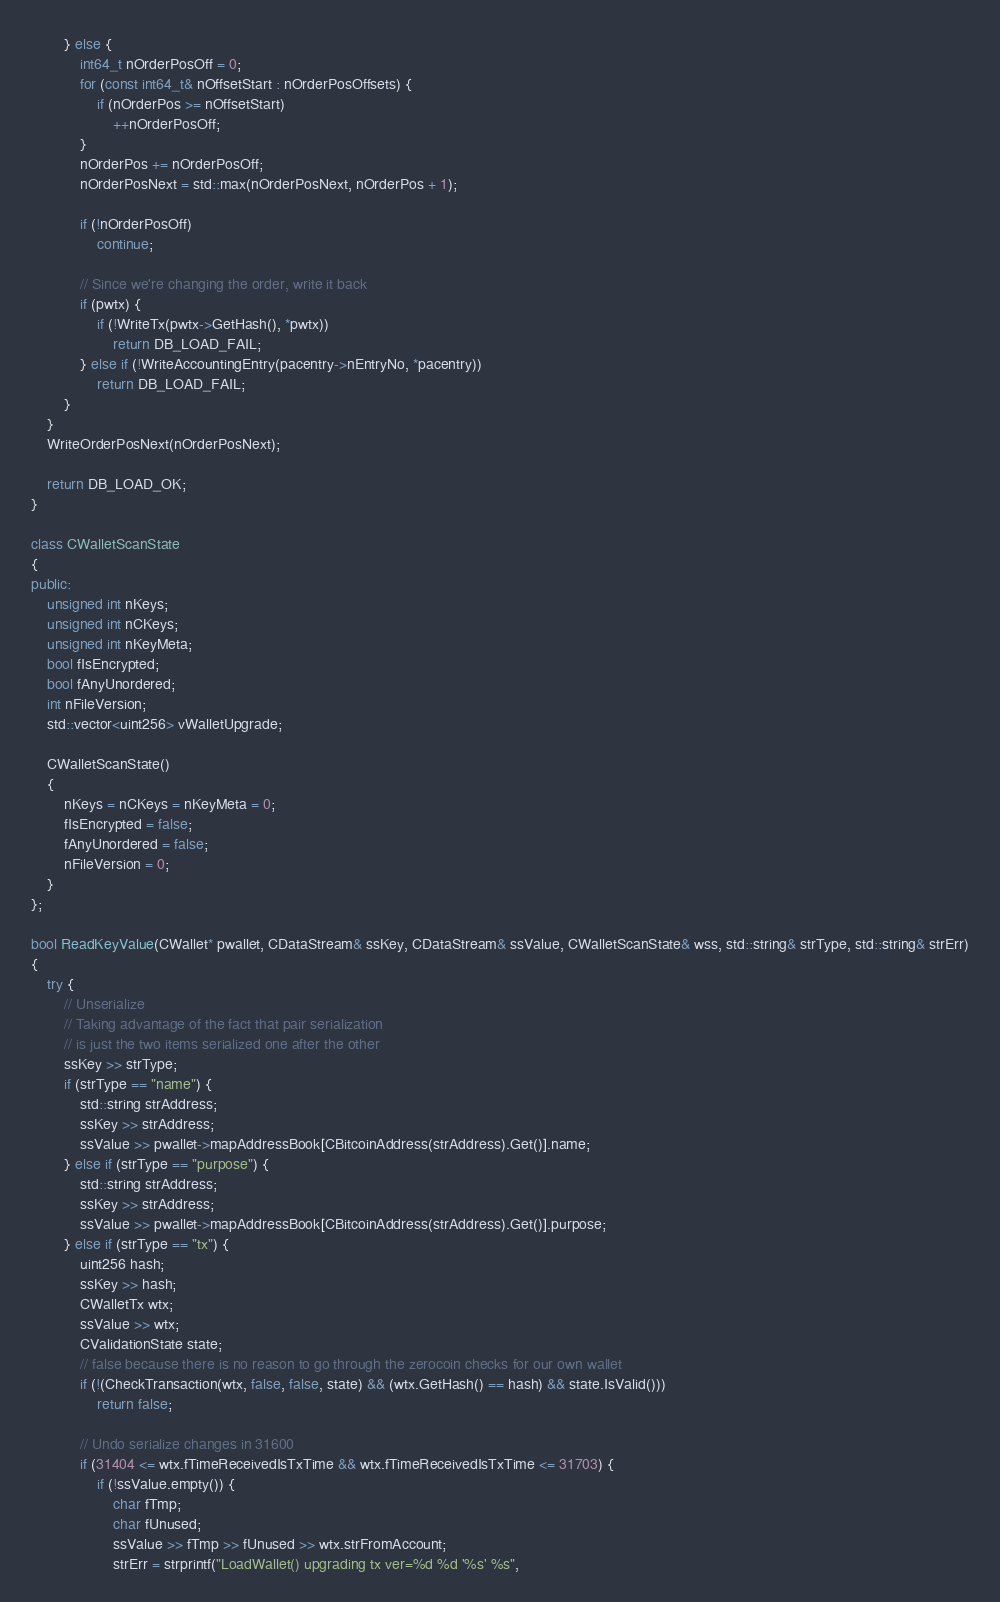Convert code to text. <code><loc_0><loc_0><loc_500><loc_500><_C++_>        } else {
            int64_t nOrderPosOff = 0;
            for (const int64_t& nOffsetStart : nOrderPosOffsets) {
                if (nOrderPos >= nOffsetStart)
                    ++nOrderPosOff;
            }
            nOrderPos += nOrderPosOff;
            nOrderPosNext = std::max(nOrderPosNext, nOrderPos + 1);

            if (!nOrderPosOff)
                continue;

            // Since we're changing the order, write it back
            if (pwtx) {
                if (!WriteTx(pwtx->GetHash(), *pwtx))
                    return DB_LOAD_FAIL;
            } else if (!WriteAccountingEntry(pacentry->nEntryNo, *pacentry))
                return DB_LOAD_FAIL;
        }
    }
    WriteOrderPosNext(nOrderPosNext);

    return DB_LOAD_OK;
}

class CWalletScanState
{
public:
    unsigned int nKeys;
    unsigned int nCKeys;
    unsigned int nKeyMeta;
    bool fIsEncrypted;
    bool fAnyUnordered;
    int nFileVersion;
    std::vector<uint256> vWalletUpgrade;

    CWalletScanState()
    {
        nKeys = nCKeys = nKeyMeta = 0;
        fIsEncrypted = false;
        fAnyUnordered = false;
        nFileVersion = 0;
    }
};

bool ReadKeyValue(CWallet* pwallet, CDataStream& ssKey, CDataStream& ssValue, CWalletScanState& wss, std::string& strType, std::string& strErr)
{
    try {
        // Unserialize
        // Taking advantage of the fact that pair serialization
        // is just the two items serialized one after the other
        ssKey >> strType;
        if (strType == "name") {
            std::string strAddress;
            ssKey >> strAddress;
            ssValue >> pwallet->mapAddressBook[CBitcoinAddress(strAddress).Get()].name;
        } else if (strType == "purpose") {
            std::string strAddress;
            ssKey >> strAddress;
            ssValue >> pwallet->mapAddressBook[CBitcoinAddress(strAddress).Get()].purpose;
        } else if (strType == "tx") {
            uint256 hash;
            ssKey >> hash;
            CWalletTx wtx;
            ssValue >> wtx;
            CValidationState state;
            // false because there is no reason to go through the zerocoin checks for our own wallet
            if (!(CheckTransaction(wtx, false, false, state) && (wtx.GetHash() == hash) && state.IsValid()))
                return false;

            // Undo serialize changes in 31600
            if (31404 <= wtx.fTimeReceivedIsTxTime && wtx.fTimeReceivedIsTxTime <= 31703) {
                if (!ssValue.empty()) {
                    char fTmp;
                    char fUnused;
                    ssValue >> fTmp >> fUnused >> wtx.strFromAccount;
                    strErr = strprintf("LoadWallet() upgrading tx ver=%d %d '%s' %s",</code> 